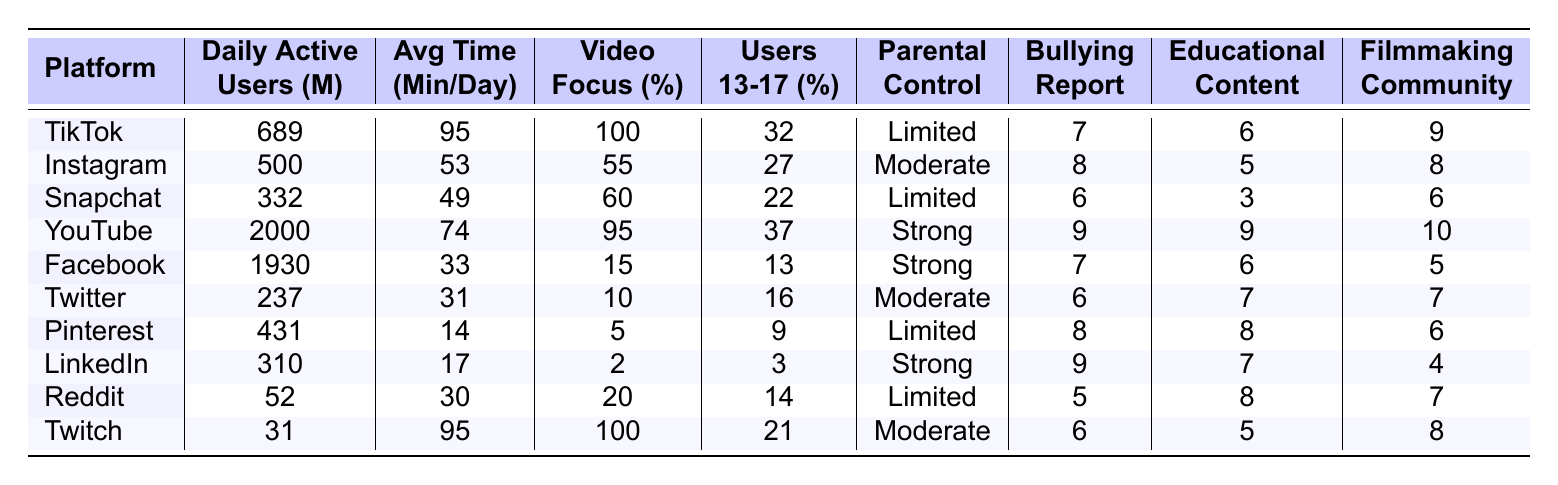What is the platform with the highest daily active users? From the table, YouTube has the highest daily active users at 2000 million.
Answer: YouTube How much time do teens spend on TikTok daily, on average? The table indicates that TikTok users spend an average of 95 minutes per day.
Answer: 95 minutes Which platform has the lowest percentage of users aged 13-17? The table shows that LinkedIn has the lowest percentage of users aged 13-17, which is 3%.
Answer: 3% Which platform ranks highest for educational content availability? YouTube has the highest score for educational content availability at 9 out of 10.
Answer: YouTube What is the average daily time spent across all platforms listed? The total time spent is (95 + 53 + 49 + 74 + 33 + 31 + 14 + 17 + 30 + 95) =  498 minutes. With 10 platforms, the average is 498/10 = 49.8 minutes.
Answer: 49.8 minutes Which platform offers the strongest parental control features? The table indicates that YouTube offers the strongest parental control features, rated as "Strong".
Answer: YouTube Is TikTok's bullying/harassment reporting ease higher than SnapChat's? TikTok has a rating of 7 for bullying reporting ease while Snapchat has a rating of 6, so yes, TikTok is higher.
Answer: Yes Compare the filmmaking community scores of YouTube and Instagram. YouTube has a filmmaking community score of 10, while Instagram scores 8; hence, YouTube has a higher score.
Answer: YouTube Which platform has the highest focus on video content, and what is that percentage? TikTok is focused entirely on video content with 100%.
Answer: TikTok, 100% How does the average time spent on Facebook compare to Snapchat? The average time for Facebook is 33 minutes, while Snapchat is 49 minutes; therefore, Snapchat users spend more time daily.
Answer: Snapchat, more time What percentage of Snapchat users are aged 13-17? The table states that 22% of Snapchat users are aged 13-17.
Answer: 22% Which social media platform has the lowest daily active users? According to the table, Twitch has the lowest daily active users at 31 million.
Answer: Twitch How does the educational content availability of Twitter compare with Reddit? Twitter has a score of 7 for educational content, while Reddit has a score of 8. Thus, Reddit scores higher.
Answer: Reddit 